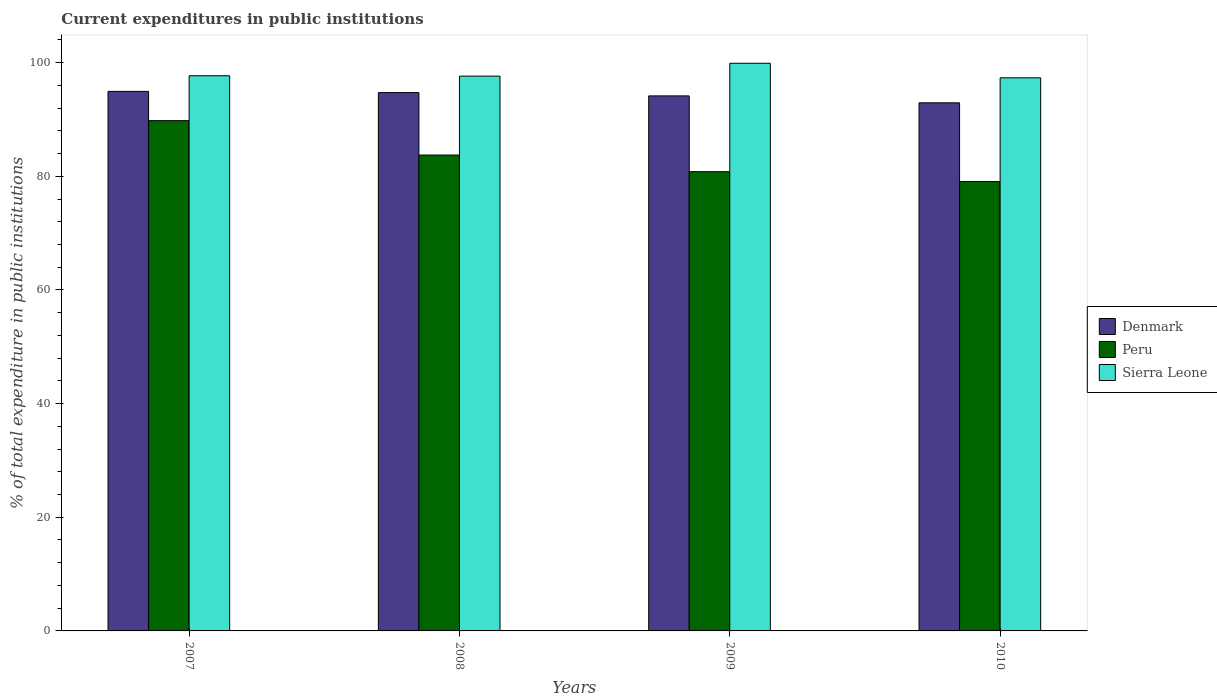How many different coloured bars are there?
Your answer should be compact. 3. Are the number of bars on each tick of the X-axis equal?
Your answer should be very brief. Yes. How many bars are there on the 3rd tick from the right?
Offer a very short reply. 3. What is the label of the 4th group of bars from the left?
Provide a succinct answer. 2010. In how many cases, is the number of bars for a given year not equal to the number of legend labels?
Keep it short and to the point. 0. What is the current expenditures in public institutions in Denmark in 2010?
Your answer should be compact. 92.93. Across all years, what is the maximum current expenditures in public institutions in Sierra Leone?
Ensure brevity in your answer.  99.89. Across all years, what is the minimum current expenditures in public institutions in Denmark?
Keep it short and to the point. 92.93. In which year was the current expenditures in public institutions in Denmark minimum?
Your response must be concise. 2010. What is the total current expenditures in public institutions in Denmark in the graph?
Your answer should be very brief. 376.74. What is the difference between the current expenditures in public institutions in Sierra Leone in 2007 and that in 2008?
Provide a succinct answer. 0.06. What is the difference between the current expenditures in public institutions in Sierra Leone in 2007 and the current expenditures in public institutions in Denmark in 2009?
Offer a terse response. 3.54. What is the average current expenditures in public institutions in Sierra Leone per year?
Provide a succinct answer. 98.13. In the year 2007, what is the difference between the current expenditures in public institutions in Sierra Leone and current expenditures in public institutions in Peru?
Provide a succinct answer. 7.9. In how many years, is the current expenditures in public institutions in Denmark greater than 76 %?
Your answer should be very brief. 4. What is the ratio of the current expenditures in public institutions in Peru in 2008 to that in 2010?
Your response must be concise. 1.06. Is the current expenditures in public institutions in Denmark in 2009 less than that in 2010?
Keep it short and to the point. No. What is the difference between the highest and the second highest current expenditures in public institutions in Peru?
Make the answer very short. 6.05. What is the difference between the highest and the lowest current expenditures in public institutions in Peru?
Provide a succinct answer. 10.71. In how many years, is the current expenditures in public institutions in Denmark greater than the average current expenditures in public institutions in Denmark taken over all years?
Provide a short and direct response. 2. What does the 2nd bar from the left in 2009 represents?
Provide a succinct answer. Peru. What does the 1st bar from the right in 2008 represents?
Give a very brief answer. Sierra Leone. Is it the case that in every year, the sum of the current expenditures in public institutions in Denmark and current expenditures in public institutions in Peru is greater than the current expenditures in public institutions in Sierra Leone?
Your answer should be very brief. Yes. How many years are there in the graph?
Keep it short and to the point. 4. What is the difference between two consecutive major ticks on the Y-axis?
Give a very brief answer. 20. Does the graph contain grids?
Offer a terse response. No. Where does the legend appear in the graph?
Keep it short and to the point. Center right. How many legend labels are there?
Ensure brevity in your answer.  3. How are the legend labels stacked?
Keep it short and to the point. Vertical. What is the title of the graph?
Give a very brief answer. Current expenditures in public institutions. Does "Myanmar" appear as one of the legend labels in the graph?
Your response must be concise. No. What is the label or title of the X-axis?
Provide a short and direct response. Years. What is the label or title of the Y-axis?
Your answer should be very brief. % of total expenditure in public institutions. What is the % of total expenditure in public institutions in Denmark in 2007?
Offer a terse response. 94.94. What is the % of total expenditure in public institutions in Peru in 2007?
Keep it short and to the point. 89.79. What is the % of total expenditure in public institutions in Sierra Leone in 2007?
Give a very brief answer. 97.69. What is the % of total expenditure in public institutions of Denmark in 2008?
Ensure brevity in your answer.  94.73. What is the % of total expenditure in public institutions of Peru in 2008?
Offer a terse response. 83.74. What is the % of total expenditure in public institutions in Sierra Leone in 2008?
Ensure brevity in your answer.  97.62. What is the % of total expenditure in public institutions in Denmark in 2009?
Provide a succinct answer. 94.15. What is the % of total expenditure in public institutions of Peru in 2009?
Make the answer very short. 80.81. What is the % of total expenditure in public institutions in Sierra Leone in 2009?
Offer a terse response. 99.89. What is the % of total expenditure in public institutions in Denmark in 2010?
Your response must be concise. 92.93. What is the % of total expenditure in public institutions in Peru in 2010?
Offer a terse response. 79.08. What is the % of total expenditure in public institutions of Sierra Leone in 2010?
Your answer should be compact. 97.33. Across all years, what is the maximum % of total expenditure in public institutions in Denmark?
Make the answer very short. 94.94. Across all years, what is the maximum % of total expenditure in public institutions in Peru?
Make the answer very short. 89.79. Across all years, what is the maximum % of total expenditure in public institutions in Sierra Leone?
Your answer should be very brief. 99.89. Across all years, what is the minimum % of total expenditure in public institutions in Denmark?
Make the answer very short. 92.93. Across all years, what is the minimum % of total expenditure in public institutions in Peru?
Offer a terse response. 79.08. Across all years, what is the minimum % of total expenditure in public institutions in Sierra Leone?
Your answer should be very brief. 97.33. What is the total % of total expenditure in public institutions of Denmark in the graph?
Provide a succinct answer. 376.74. What is the total % of total expenditure in public institutions of Peru in the graph?
Your answer should be compact. 333.42. What is the total % of total expenditure in public institutions of Sierra Leone in the graph?
Provide a succinct answer. 392.53. What is the difference between the % of total expenditure in public institutions of Denmark in 2007 and that in 2008?
Give a very brief answer. 0.22. What is the difference between the % of total expenditure in public institutions in Peru in 2007 and that in 2008?
Ensure brevity in your answer.  6.05. What is the difference between the % of total expenditure in public institutions of Sierra Leone in 2007 and that in 2008?
Keep it short and to the point. 0.06. What is the difference between the % of total expenditure in public institutions of Denmark in 2007 and that in 2009?
Make the answer very short. 0.8. What is the difference between the % of total expenditure in public institutions of Peru in 2007 and that in 2009?
Give a very brief answer. 8.98. What is the difference between the % of total expenditure in public institutions of Sierra Leone in 2007 and that in 2009?
Your answer should be compact. -2.2. What is the difference between the % of total expenditure in public institutions in Denmark in 2007 and that in 2010?
Your answer should be very brief. 2.02. What is the difference between the % of total expenditure in public institutions of Peru in 2007 and that in 2010?
Your response must be concise. 10.71. What is the difference between the % of total expenditure in public institutions of Sierra Leone in 2007 and that in 2010?
Keep it short and to the point. 0.36. What is the difference between the % of total expenditure in public institutions of Denmark in 2008 and that in 2009?
Keep it short and to the point. 0.58. What is the difference between the % of total expenditure in public institutions in Peru in 2008 and that in 2009?
Keep it short and to the point. 2.92. What is the difference between the % of total expenditure in public institutions in Sierra Leone in 2008 and that in 2009?
Ensure brevity in your answer.  -2.26. What is the difference between the % of total expenditure in public institutions in Denmark in 2008 and that in 2010?
Give a very brief answer. 1.8. What is the difference between the % of total expenditure in public institutions of Peru in 2008 and that in 2010?
Provide a succinct answer. 4.66. What is the difference between the % of total expenditure in public institutions in Sierra Leone in 2008 and that in 2010?
Keep it short and to the point. 0.3. What is the difference between the % of total expenditure in public institutions in Denmark in 2009 and that in 2010?
Provide a succinct answer. 1.22. What is the difference between the % of total expenditure in public institutions of Peru in 2009 and that in 2010?
Provide a succinct answer. 1.74. What is the difference between the % of total expenditure in public institutions of Sierra Leone in 2009 and that in 2010?
Your response must be concise. 2.56. What is the difference between the % of total expenditure in public institutions in Denmark in 2007 and the % of total expenditure in public institutions in Peru in 2008?
Keep it short and to the point. 11.21. What is the difference between the % of total expenditure in public institutions in Denmark in 2007 and the % of total expenditure in public institutions in Sierra Leone in 2008?
Give a very brief answer. -2.68. What is the difference between the % of total expenditure in public institutions of Peru in 2007 and the % of total expenditure in public institutions of Sierra Leone in 2008?
Make the answer very short. -7.83. What is the difference between the % of total expenditure in public institutions of Denmark in 2007 and the % of total expenditure in public institutions of Peru in 2009?
Your answer should be compact. 14.13. What is the difference between the % of total expenditure in public institutions in Denmark in 2007 and the % of total expenditure in public institutions in Sierra Leone in 2009?
Offer a very short reply. -4.95. What is the difference between the % of total expenditure in public institutions of Peru in 2007 and the % of total expenditure in public institutions of Sierra Leone in 2009?
Ensure brevity in your answer.  -10.1. What is the difference between the % of total expenditure in public institutions of Denmark in 2007 and the % of total expenditure in public institutions of Peru in 2010?
Give a very brief answer. 15.86. What is the difference between the % of total expenditure in public institutions in Denmark in 2007 and the % of total expenditure in public institutions in Sierra Leone in 2010?
Your answer should be very brief. -2.38. What is the difference between the % of total expenditure in public institutions in Peru in 2007 and the % of total expenditure in public institutions in Sierra Leone in 2010?
Make the answer very short. -7.54. What is the difference between the % of total expenditure in public institutions in Denmark in 2008 and the % of total expenditure in public institutions in Peru in 2009?
Keep it short and to the point. 13.91. What is the difference between the % of total expenditure in public institutions of Denmark in 2008 and the % of total expenditure in public institutions of Sierra Leone in 2009?
Your response must be concise. -5.16. What is the difference between the % of total expenditure in public institutions in Peru in 2008 and the % of total expenditure in public institutions in Sierra Leone in 2009?
Keep it short and to the point. -16.15. What is the difference between the % of total expenditure in public institutions of Denmark in 2008 and the % of total expenditure in public institutions of Peru in 2010?
Keep it short and to the point. 15.65. What is the difference between the % of total expenditure in public institutions in Denmark in 2008 and the % of total expenditure in public institutions in Sierra Leone in 2010?
Provide a succinct answer. -2.6. What is the difference between the % of total expenditure in public institutions of Peru in 2008 and the % of total expenditure in public institutions of Sierra Leone in 2010?
Offer a very short reply. -13.59. What is the difference between the % of total expenditure in public institutions of Denmark in 2009 and the % of total expenditure in public institutions of Peru in 2010?
Offer a terse response. 15.07. What is the difference between the % of total expenditure in public institutions in Denmark in 2009 and the % of total expenditure in public institutions in Sierra Leone in 2010?
Offer a very short reply. -3.18. What is the difference between the % of total expenditure in public institutions in Peru in 2009 and the % of total expenditure in public institutions in Sierra Leone in 2010?
Offer a terse response. -16.51. What is the average % of total expenditure in public institutions of Denmark per year?
Your response must be concise. 94.19. What is the average % of total expenditure in public institutions in Peru per year?
Give a very brief answer. 83.35. What is the average % of total expenditure in public institutions in Sierra Leone per year?
Your answer should be very brief. 98.13. In the year 2007, what is the difference between the % of total expenditure in public institutions of Denmark and % of total expenditure in public institutions of Peru?
Offer a very short reply. 5.15. In the year 2007, what is the difference between the % of total expenditure in public institutions of Denmark and % of total expenditure in public institutions of Sierra Leone?
Provide a short and direct response. -2.74. In the year 2007, what is the difference between the % of total expenditure in public institutions in Peru and % of total expenditure in public institutions in Sierra Leone?
Give a very brief answer. -7.9. In the year 2008, what is the difference between the % of total expenditure in public institutions of Denmark and % of total expenditure in public institutions of Peru?
Your answer should be very brief. 10.99. In the year 2008, what is the difference between the % of total expenditure in public institutions in Denmark and % of total expenditure in public institutions in Sierra Leone?
Offer a terse response. -2.9. In the year 2008, what is the difference between the % of total expenditure in public institutions of Peru and % of total expenditure in public institutions of Sierra Leone?
Your answer should be compact. -13.89. In the year 2009, what is the difference between the % of total expenditure in public institutions in Denmark and % of total expenditure in public institutions in Peru?
Provide a short and direct response. 13.33. In the year 2009, what is the difference between the % of total expenditure in public institutions of Denmark and % of total expenditure in public institutions of Sierra Leone?
Offer a terse response. -5.74. In the year 2009, what is the difference between the % of total expenditure in public institutions in Peru and % of total expenditure in public institutions in Sierra Leone?
Your response must be concise. -19.08. In the year 2010, what is the difference between the % of total expenditure in public institutions in Denmark and % of total expenditure in public institutions in Peru?
Give a very brief answer. 13.85. In the year 2010, what is the difference between the % of total expenditure in public institutions in Denmark and % of total expenditure in public institutions in Sierra Leone?
Give a very brief answer. -4.4. In the year 2010, what is the difference between the % of total expenditure in public institutions in Peru and % of total expenditure in public institutions in Sierra Leone?
Keep it short and to the point. -18.25. What is the ratio of the % of total expenditure in public institutions of Denmark in 2007 to that in 2008?
Give a very brief answer. 1. What is the ratio of the % of total expenditure in public institutions of Peru in 2007 to that in 2008?
Offer a very short reply. 1.07. What is the ratio of the % of total expenditure in public institutions of Sierra Leone in 2007 to that in 2008?
Offer a very short reply. 1. What is the ratio of the % of total expenditure in public institutions of Denmark in 2007 to that in 2009?
Make the answer very short. 1.01. What is the ratio of the % of total expenditure in public institutions of Denmark in 2007 to that in 2010?
Ensure brevity in your answer.  1.02. What is the ratio of the % of total expenditure in public institutions of Peru in 2007 to that in 2010?
Provide a short and direct response. 1.14. What is the ratio of the % of total expenditure in public institutions in Sierra Leone in 2007 to that in 2010?
Provide a succinct answer. 1. What is the ratio of the % of total expenditure in public institutions in Peru in 2008 to that in 2009?
Your answer should be compact. 1.04. What is the ratio of the % of total expenditure in public institutions of Sierra Leone in 2008 to that in 2009?
Offer a terse response. 0.98. What is the ratio of the % of total expenditure in public institutions of Denmark in 2008 to that in 2010?
Give a very brief answer. 1.02. What is the ratio of the % of total expenditure in public institutions of Peru in 2008 to that in 2010?
Offer a terse response. 1.06. What is the ratio of the % of total expenditure in public institutions of Sierra Leone in 2008 to that in 2010?
Provide a succinct answer. 1. What is the ratio of the % of total expenditure in public institutions in Denmark in 2009 to that in 2010?
Keep it short and to the point. 1.01. What is the ratio of the % of total expenditure in public institutions in Peru in 2009 to that in 2010?
Keep it short and to the point. 1.02. What is the ratio of the % of total expenditure in public institutions of Sierra Leone in 2009 to that in 2010?
Offer a very short reply. 1.03. What is the difference between the highest and the second highest % of total expenditure in public institutions in Denmark?
Keep it short and to the point. 0.22. What is the difference between the highest and the second highest % of total expenditure in public institutions of Peru?
Give a very brief answer. 6.05. What is the difference between the highest and the second highest % of total expenditure in public institutions of Sierra Leone?
Ensure brevity in your answer.  2.2. What is the difference between the highest and the lowest % of total expenditure in public institutions of Denmark?
Provide a short and direct response. 2.02. What is the difference between the highest and the lowest % of total expenditure in public institutions of Peru?
Keep it short and to the point. 10.71. What is the difference between the highest and the lowest % of total expenditure in public institutions of Sierra Leone?
Ensure brevity in your answer.  2.56. 